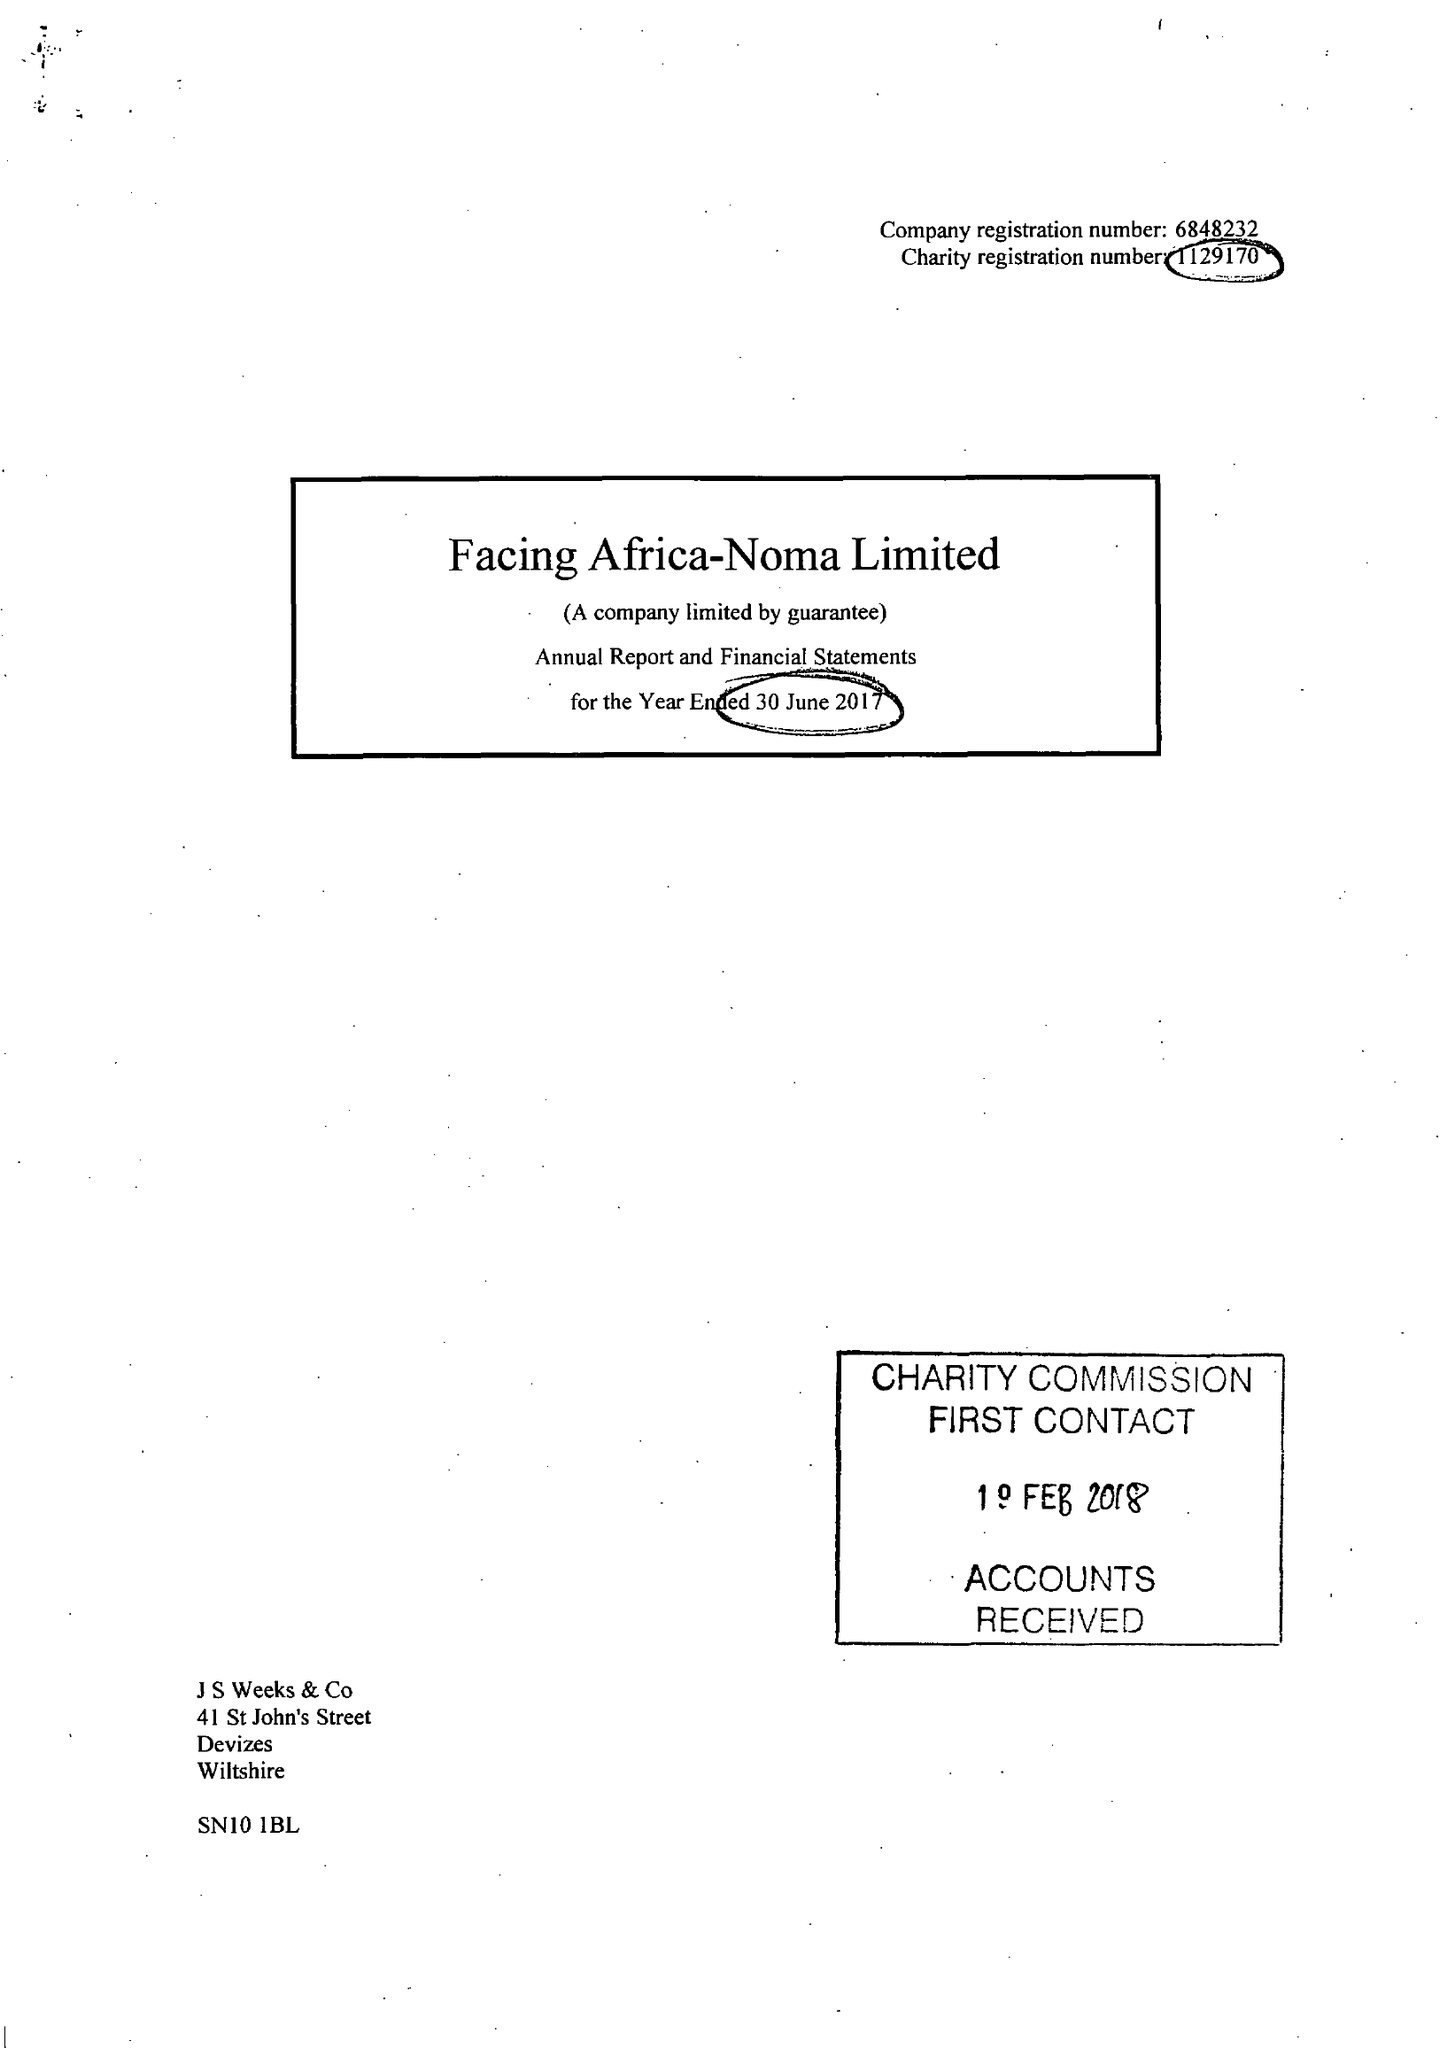What is the value for the charity_number?
Answer the question using a single word or phrase. 1129170 